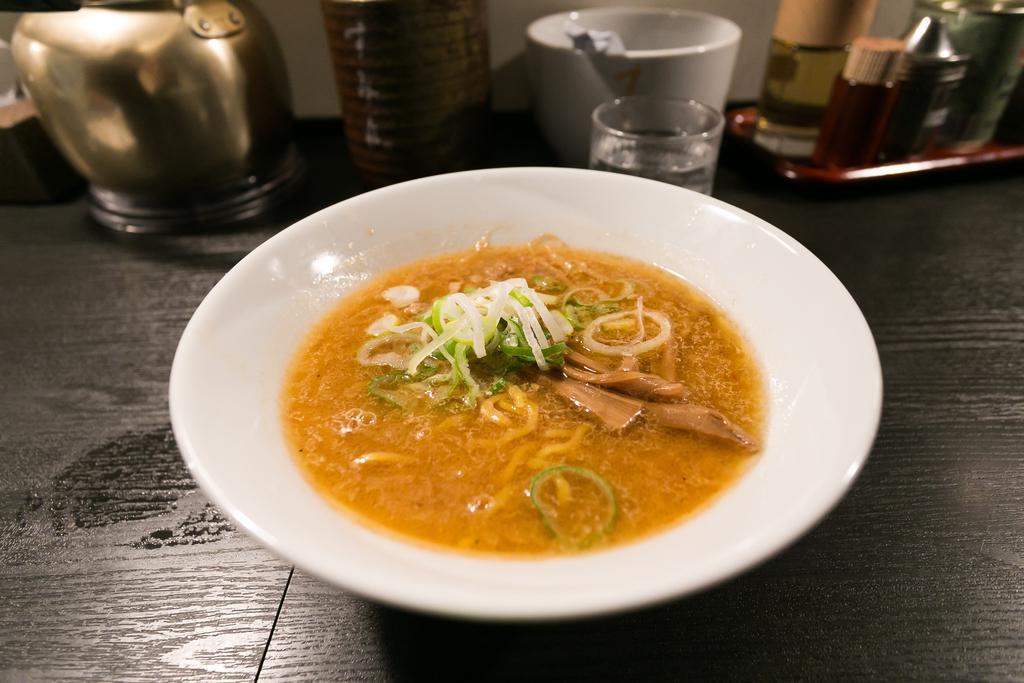Please provide a concise description of this image. In this image, we can see a plate contains some food. There is a kettle in the top left of the image. There is a cup and glass at the top of the image. There are bottles in the top right of the image. 